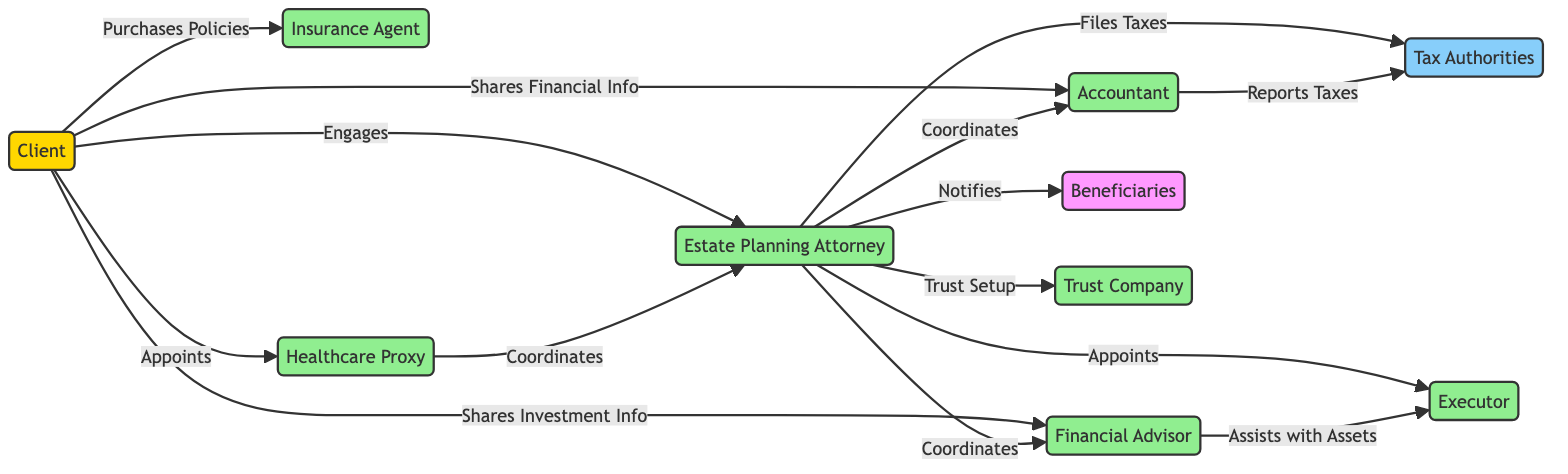What are the key entities involved in estate planning? The diagram includes several nodes representing key entities: Client, Estate Planning Attorney, Accountant, Financial Advisor, Tax Authorities, Executor, Beneficiaries, Trust Company, Insurance Agent, and Healthcare Proxy.
Answer: Client, Estate Planning Attorney, Accountant, Financial Advisor, Tax Authorities, Executor, Beneficiaries, Trust Company, Insurance Agent, Healthcare Proxy How many connections does the Estate Planning Attorney have? By counting the edges coming from the Estate Planning Attorney node, we can see that it has six outgoing connections: to Accountant, Financial Advisor, Tax Authorities, Executor, Beneficiaries, and Trust Company.
Answer: Six What action does the Client take to interact with the Financial Advisor? The diagram shows the interaction from Client to Financial Advisor labeled as "Shares Investment Info," indicating that this is the action the Client takes.
Answer: Shares Investment Info Which entity is responsible for reporting taxes? The edge from Accountant to Tax Authorities is labeled "Reports Taxes," indicating that the Accountant has this responsibility.
Answer: Accountant Who does the Healthcare Proxy coordinate with? The edge from Healthcare Proxy to Estate Planning Attorney is labeled "Coordinates," showing that the Healthcare Proxy interacts with the Estate Planning Attorney.
Answer: Estate Planning Attorney How many edges are present in the diagram? Counting the edges listed in the data, there are a total of 12 connections or interactions among the entities in the diagram.
Answer: Twelve What is the relationship between the Estate Planning Attorney and Executor? The edge connecting these two nodes is labeled "Appoints," indicating that the Estate Planning Attorney appoints the Executor in the estate planning process.
Answer: Appoints Which entity does the Client appoint along with the Healthcare Proxy? The diagram indicates that the Client appoints both a Healthcare Proxy and, through the edge from Estate Planning Attorney, an Executor. Both entities are appointed in the context of estate planning.
Answer: Executor 